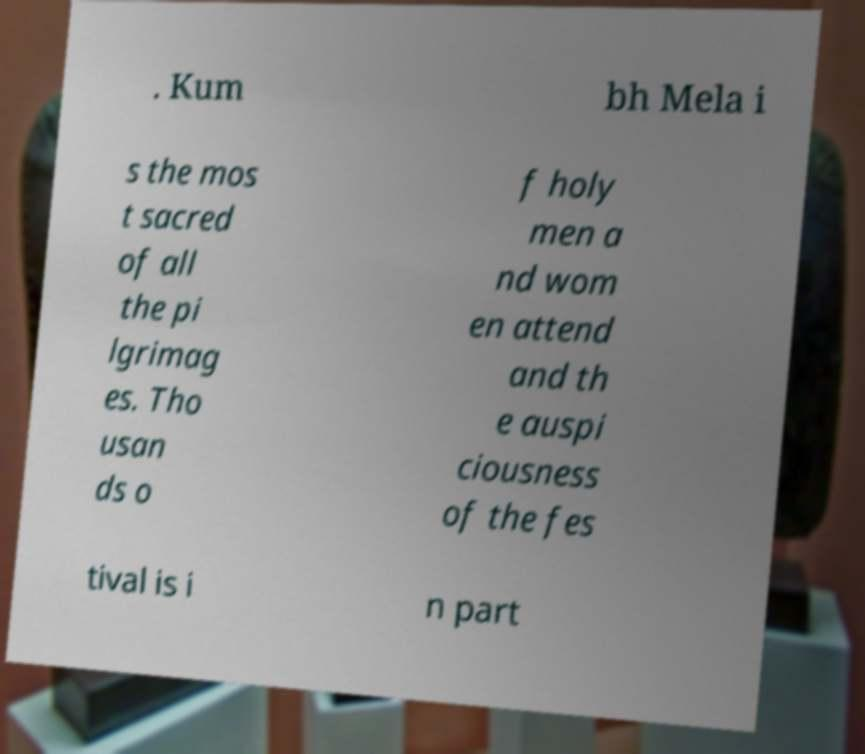Can you accurately transcribe the text from the provided image for me? . Kum bh Mela i s the mos t sacred of all the pi lgrimag es. Tho usan ds o f holy men a nd wom en attend and th e auspi ciousness of the fes tival is i n part 